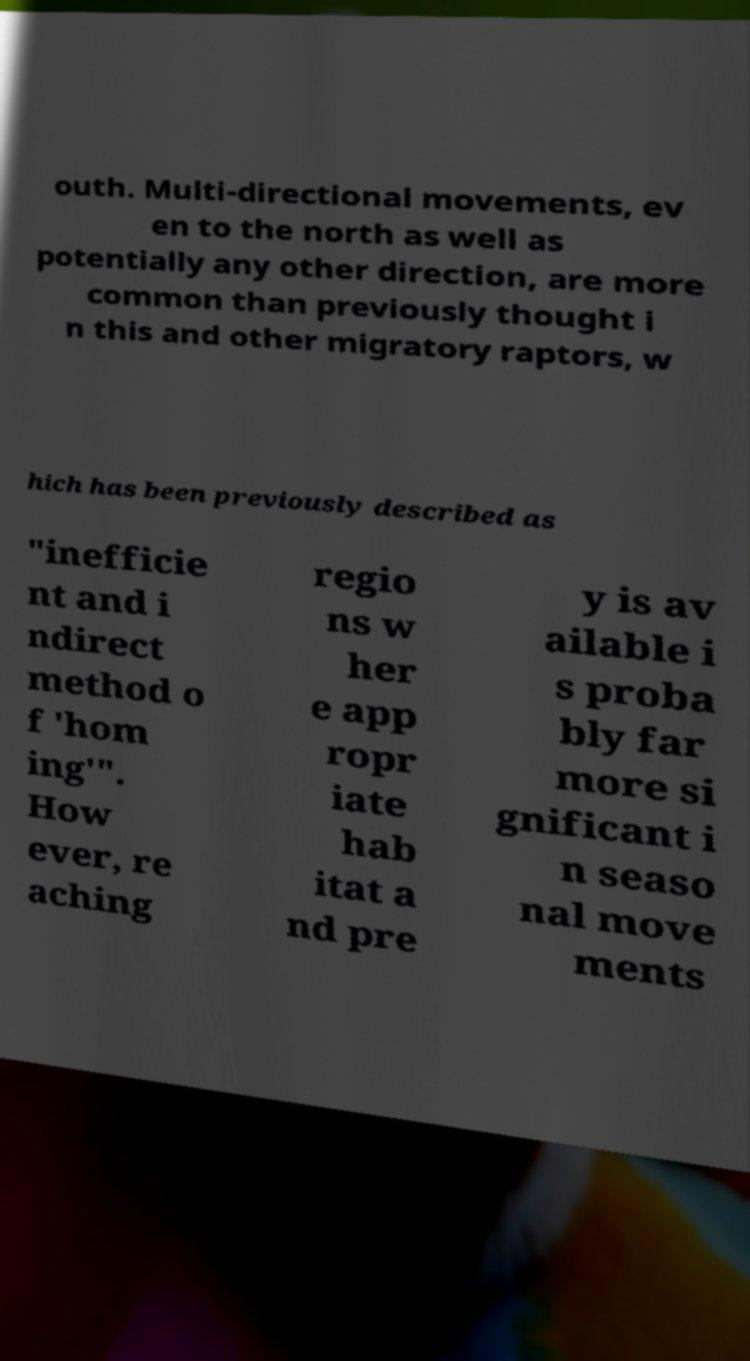Could you assist in decoding the text presented in this image and type it out clearly? outh. Multi-directional movements, ev en to the north as well as potentially any other direction, are more common than previously thought i n this and other migratory raptors, w hich has been previously described as "inefficie nt and i ndirect method o f 'hom ing'". How ever, re aching regio ns w her e app ropr iate hab itat a nd pre y is av ailable i s proba bly far more si gnificant i n seaso nal move ments 